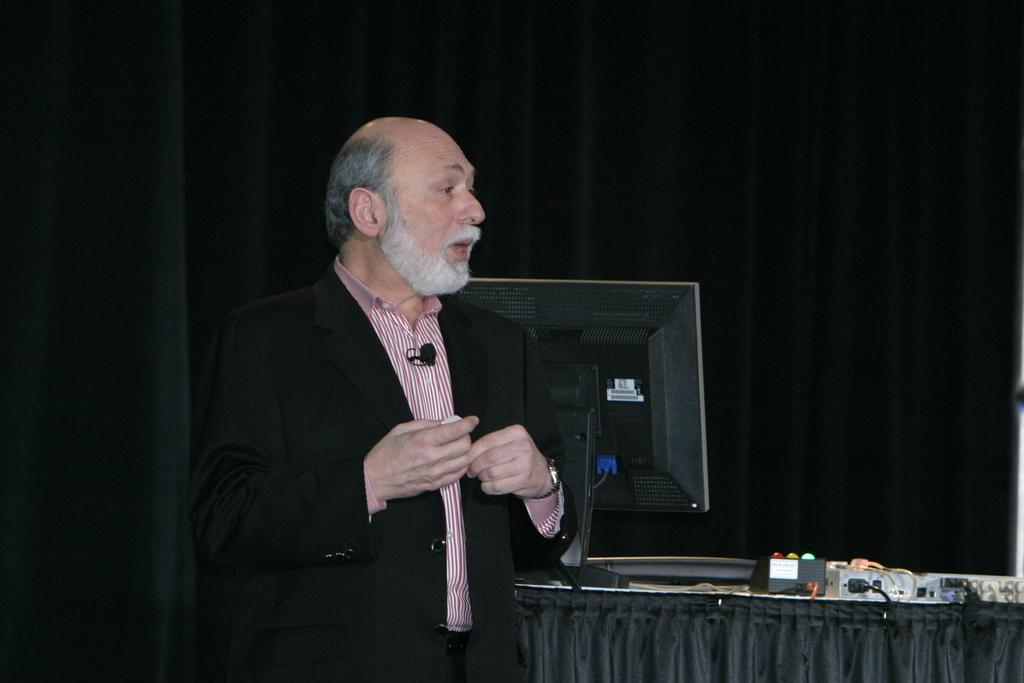Can you describe this image briefly? In this picture we can see a man, monitor, devices, cloth, some objects and in the background it is dark. 